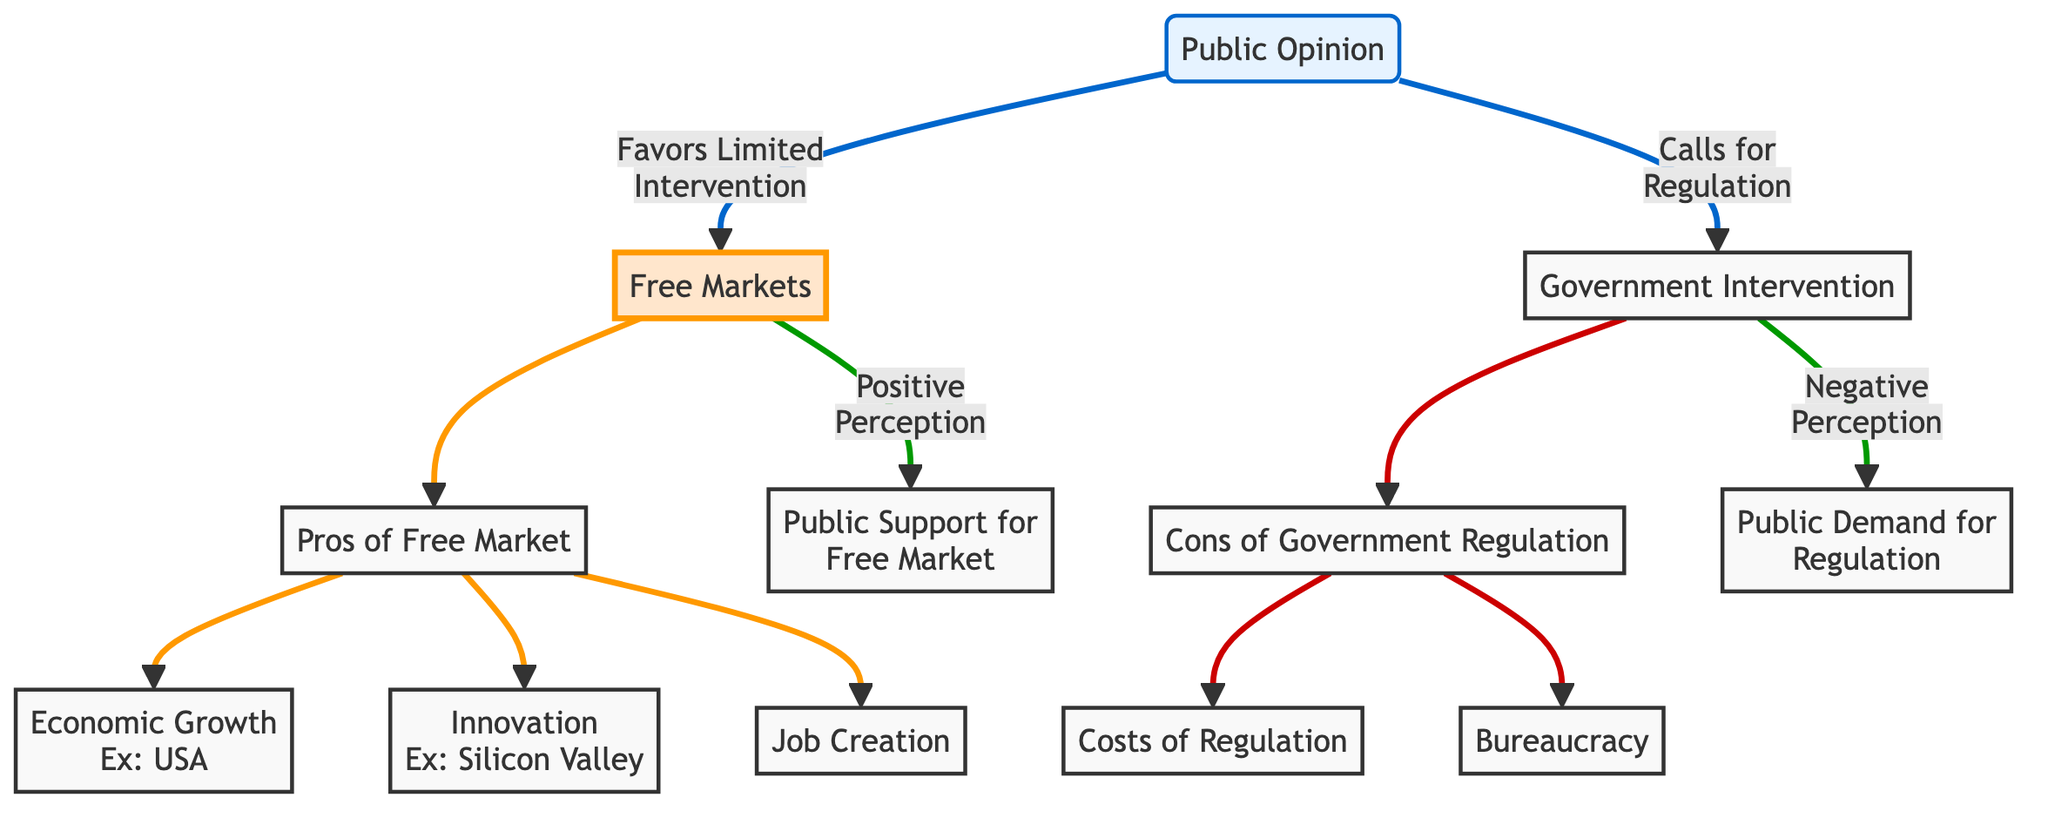What is the main opinion expressed in the diagram? The diagram shows that public opinion favors limited intervention, leading to the promotion of free markets. The node "Public Opinion" points towards "Free Markets," indicating this preference.
Answer: Free Markets Which economic aspect is associated with the "Pros of Free Market"? The "Pros of Free Market" node connects to three aspects: "Economic Growth," "Innovation," and "Job Creation." Each of these represents a benefit of a free market system.
Answer: Economic Growth, Innovation, Job Creation What negative consequence is linked to "Government Intervention"? The "Government Intervention" node leads to "Cons of Government Regulation," which has two aspects: "Costs of Regulation" and "Bureaucracy." These are the negative outcomes associated with government rules and regulations.
Answer: Costs of Regulation, Bureaucracy How many nodes are connected to "Public Opinion"? The "Public Opinion" node has two direct connections: one to "Free Markets" and one to "Government Intervention." Therefore, there are two connected nodes.
Answer: 2 What does the arrow between "Free Markets" and "Public Support for Free Market" indicate? The arrow indicates a positive relationship where the free market is favorably perceived by the public, leading to greater support. It shows a direct influence from "Free Markets" to "Public Support for Free Market."
Answer: Positive Perception Which node is connected to a negative perception in the diagram? The connection from "Government Intervention" to "Public Demand for Regulation" indicates a negative perception. It shows that government actions may lead to a demand for more regulation, reflecting an unfavorable view.
Answer: Public Demand for Regulation What is the relationship between "Free Markets" and "Job Creation"? "Job Creation" is a specific benefit that arises from the "Pros of Free Market," linking it directly as an advantage of supporting free market principles.
Answer: Pros of Free Market Which node represents a specific example of economic growth? The node "Economic Growth" is connected to the example "USA," which illustrates a case of growth resulting from free market practices, reinforcing the benefits stated in the diagram.
Answer: USA 